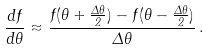<formula> <loc_0><loc_0><loc_500><loc_500>\frac { d f } { d \theta } \approx \frac { f ( \theta + \frac { \Delta \theta } { 2 } ) - f ( \theta - \frac { \Delta \theta } { 2 } ) } { \Delta \theta } \, .</formula> 